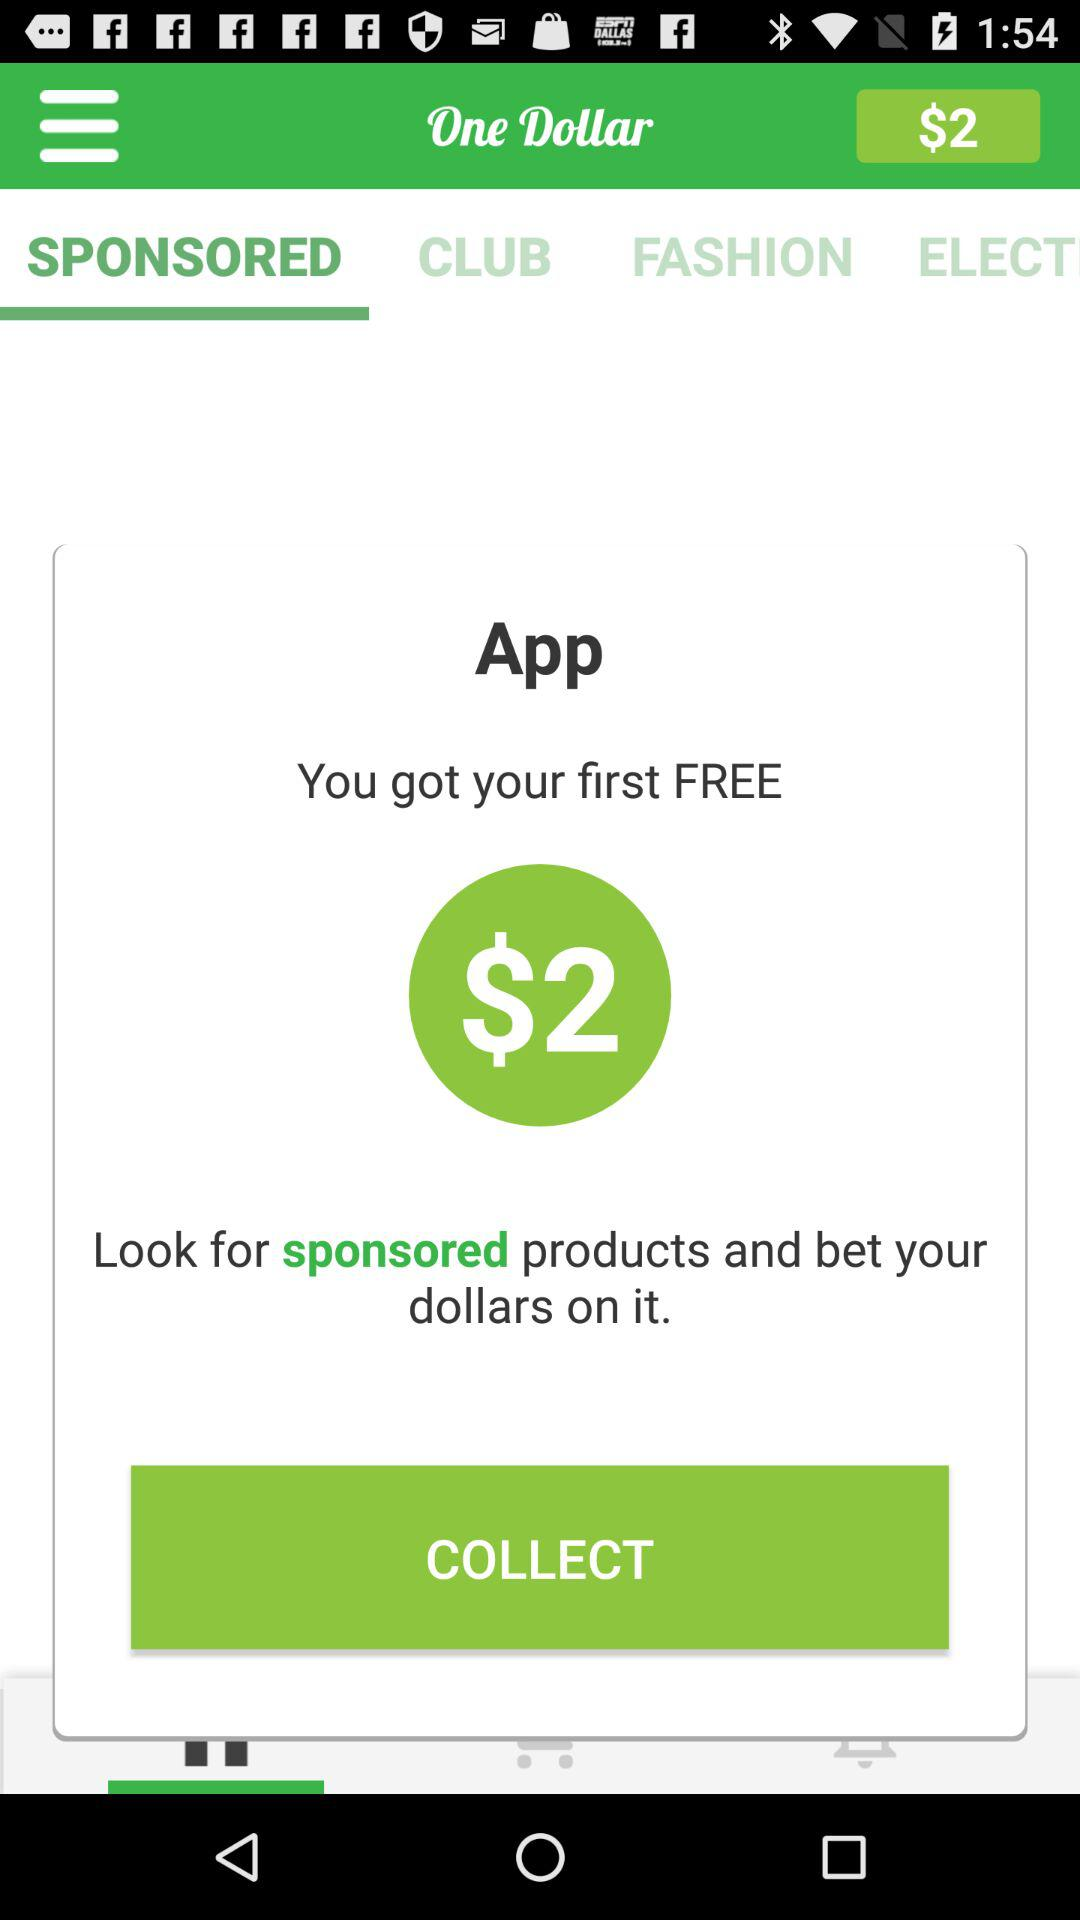What is the name of the application? The name of the application is "One Dollar". 